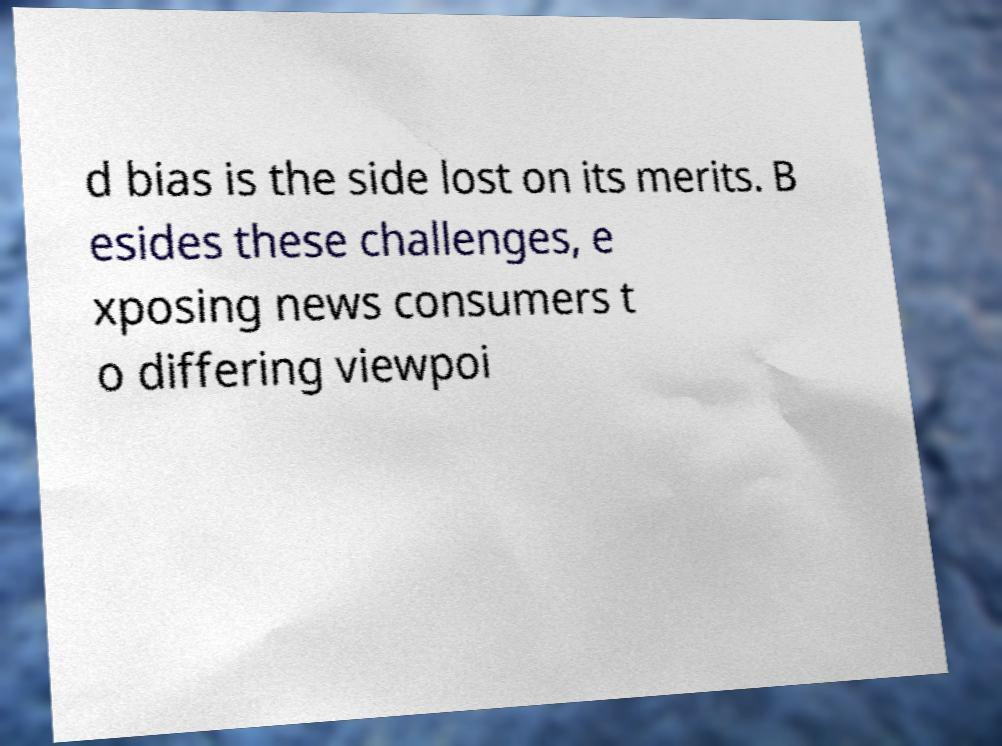Please read and relay the text visible in this image. What does it say? d bias is the side lost on its merits. B esides these challenges, e xposing news consumers t o differing viewpoi 